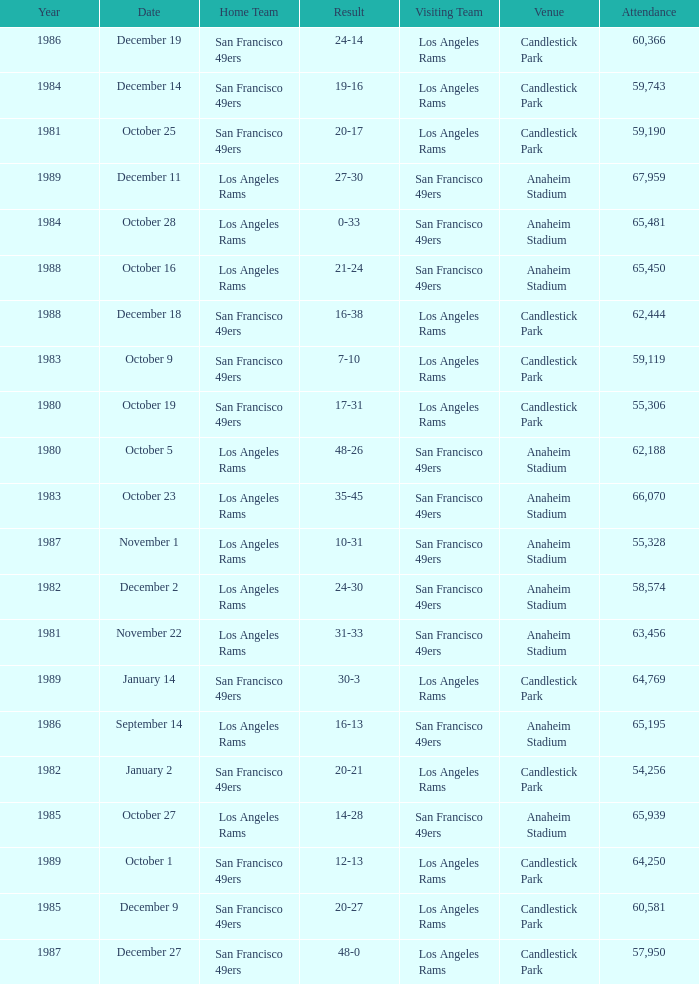What's the total attendance at anaheim stadium after 1983 when the result is 14-28? 1.0. Can you parse all the data within this table? {'header': ['Year', 'Date', 'Home Team', 'Result', 'Visiting Team', 'Venue', 'Attendance'], 'rows': [['1986', 'December 19', 'San Francisco 49ers', '24-14', 'Los Angeles Rams', 'Candlestick Park', '60,366'], ['1984', 'December 14', 'San Francisco 49ers', '19-16', 'Los Angeles Rams', 'Candlestick Park', '59,743'], ['1981', 'October 25', 'San Francisco 49ers', '20-17', 'Los Angeles Rams', 'Candlestick Park', '59,190'], ['1989', 'December 11', 'Los Angeles Rams', '27-30', 'San Francisco 49ers', 'Anaheim Stadium', '67,959'], ['1984', 'October 28', 'Los Angeles Rams', '0-33', 'San Francisco 49ers', 'Anaheim Stadium', '65,481'], ['1988', 'October 16', 'Los Angeles Rams', '21-24', 'San Francisco 49ers', 'Anaheim Stadium', '65,450'], ['1988', 'December 18', 'San Francisco 49ers', '16-38', 'Los Angeles Rams', 'Candlestick Park', '62,444'], ['1983', 'October 9', 'San Francisco 49ers', '7-10', 'Los Angeles Rams', 'Candlestick Park', '59,119'], ['1980', 'October 19', 'San Francisco 49ers', '17-31', 'Los Angeles Rams', 'Candlestick Park', '55,306'], ['1980', 'October 5', 'Los Angeles Rams', '48-26', 'San Francisco 49ers', 'Anaheim Stadium', '62,188'], ['1983', 'October 23', 'Los Angeles Rams', '35-45', 'San Francisco 49ers', 'Anaheim Stadium', '66,070'], ['1987', 'November 1', 'Los Angeles Rams', '10-31', 'San Francisco 49ers', 'Anaheim Stadium', '55,328'], ['1982', 'December 2', 'Los Angeles Rams', '24-30', 'San Francisco 49ers', 'Anaheim Stadium', '58,574'], ['1981', 'November 22', 'Los Angeles Rams', '31-33', 'San Francisco 49ers', 'Anaheim Stadium', '63,456'], ['1989', 'January 14', 'San Francisco 49ers', '30-3', 'Los Angeles Rams', 'Candlestick Park', '64,769'], ['1986', 'September 14', 'Los Angeles Rams', '16-13', 'San Francisco 49ers', 'Anaheim Stadium', '65,195'], ['1982', 'January 2', 'San Francisco 49ers', '20-21', 'Los Angeles Rams', 'Candlestick Park', '54,256'], ['1985', 'October 27', 'Los Angeles Rams', '14-28', 'San Francisco 49ers', 'Anaheim Stadium', '65,939'], ['1989', 'October 1', 'San Francisco 49ers', '12-13', 'Los Angeles Rams', 'Candlestick Park', '64,250'], ['1985', 'December 9', 'San Francisco 49ers', '20-27', 'Los Angeles Rams', 'Candlestick Park', '60,581'], ['1987', 'December 27', 'San Francisco 49ers', '48-0', 'Los Angeles Rams', 'Candlestick Park', '57,950']]} 